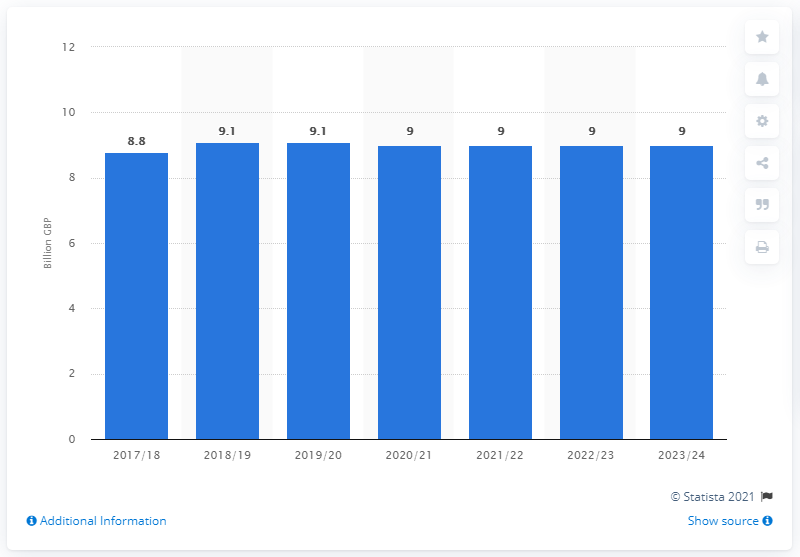Draw attention to some important aspects in this diagram. The total amount of tobacco duties in the UK in 2023/24 was $9 million. 